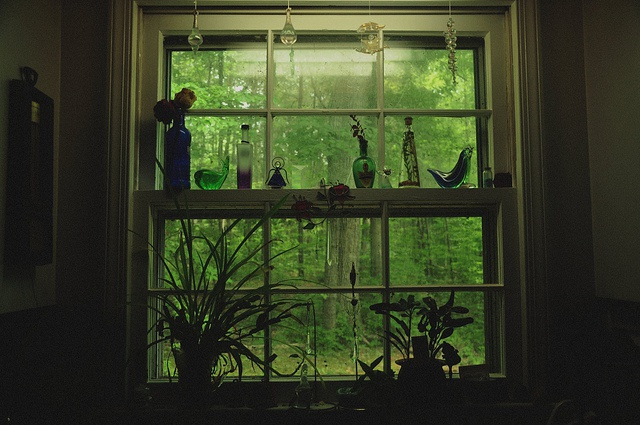Describe the objects in this image and their specific colors. I can see potted plant in black, darkgreen, and green tones, potted plant in black, darkgreen, and green tones, vase in black and darkgreen tones, bottle in black, darkgreen, green, and navy tones, and vase in black, darkgreen, green, and navy tones in this image. 